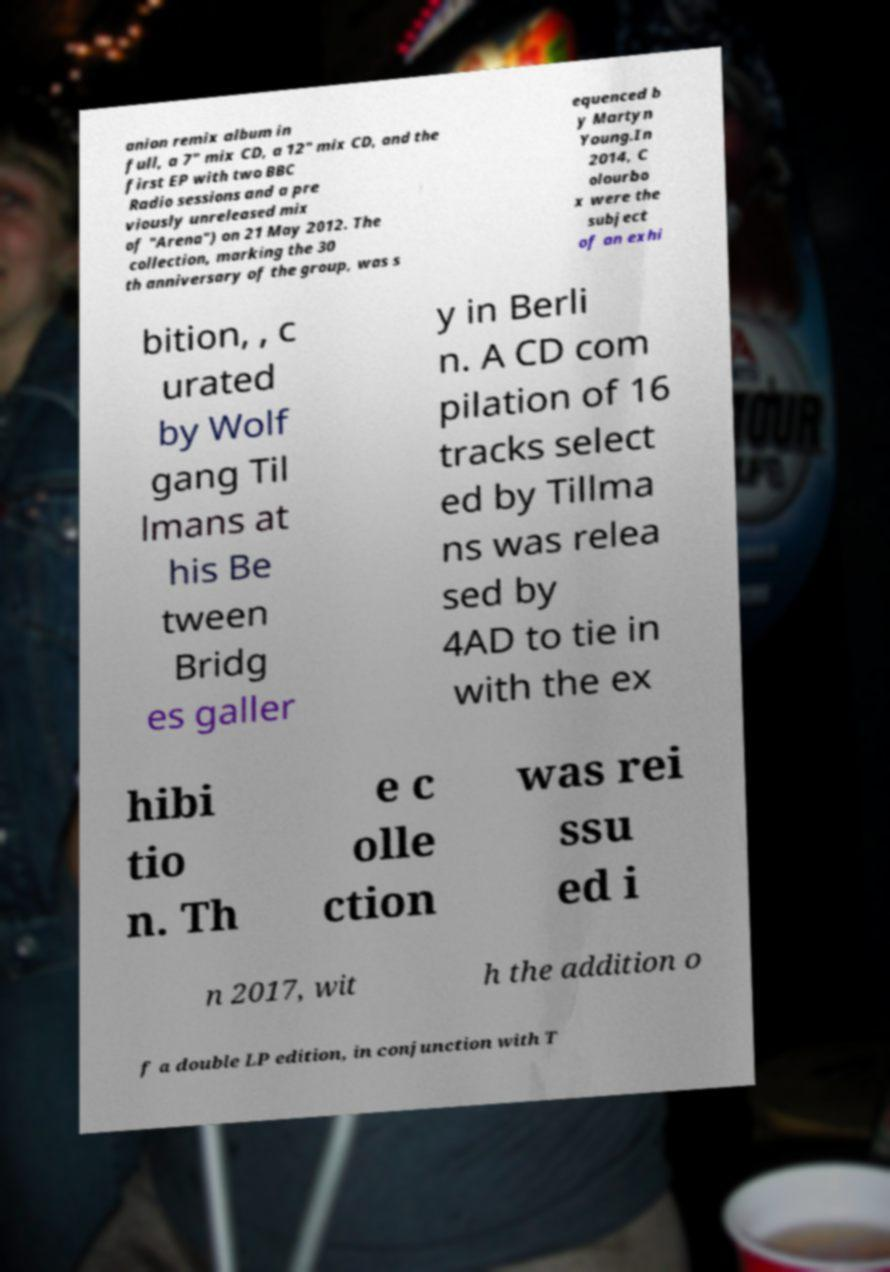I need the written content from this picture converted into text. Can you do that? anion remix album in full, a 7" mix CD, a 12" mix CD, and the first EP with two BBC Radio sessions and a pre viously unreleased mix of "Arena") on 21 May 2012. The collection, marking the 30 th anniversary of the group, was s equenced b y Martyn Young.In 2014, C olourbo x were the subject of an exhi bition, , c urated by Wolf gang Til lmans at his Be tween Bridg es galler y in Berli n. A CD com pilation of 16 tracks select ed by Tillma ns was relea sed by 4AD to tie in with the ex hibi tio n. Th e c olle ction was rei ssu ed i n 2017, wit h the addition o f a double LP edition, in conjunction with T 